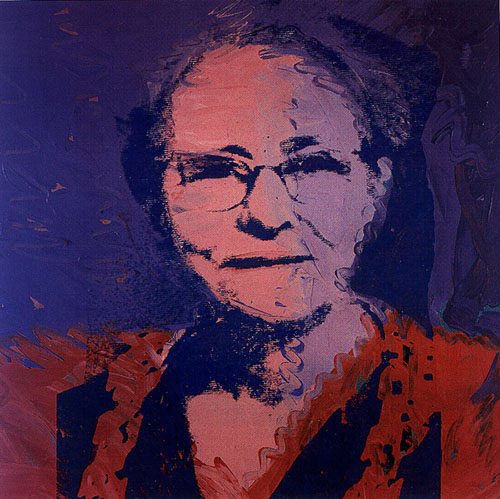Can you describe the emotion conveyed by the woman's expression in the portrait? The woman's expression in the portrait conveys a sense of calm and introspection. Her gaze, though obscured by her glasses, appears thoughtful and serene. There is a subtle serenity in her facial features, which, combined with the gentle hues and bold colors, suggests a sense of resilience and wisdom. What do the colors used in the background signify in relation to the woman depicted? The colors in the background—deep blue, orange, and purple—add layers of meaning to the portrait. The deep blue suggests a sense of depth and contemplation, providing a serene contrast to the vibrant orange and purple hues. These latter colors introduce a sense of energy and dynamism, possibly reflecting the woman's inner strength and vibrant personality. The interplay of these colors enhances the emotional depth of the portrait, making it not only visually striking but also emotionally evocative. If this woman could speak, what might she tell us about her life experiences? If this woman could speak, she might share stories of resilience and perseverance through life's challenges. Her calm demeanor and thoughtful expression suggest a person who has faced adversity with grace. She might talk about the importance of remaining true to oneself, the value of wisdom gained through experience, and the strength found in quiet moments of introspection. Her vibrant attire could hint at a passionate personality, someone who believes in living life fully and embracing every moment with courage and confidence. 